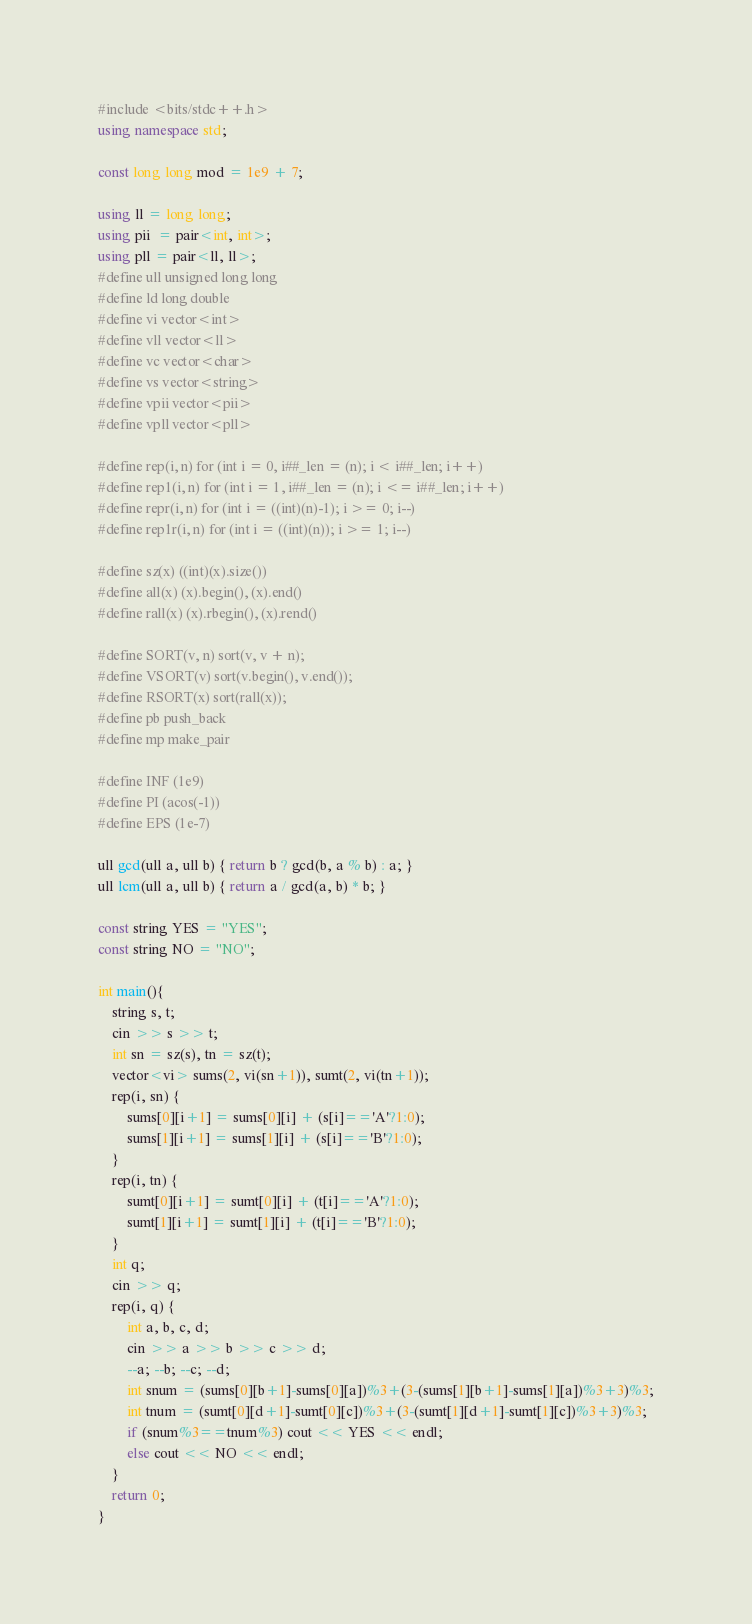Convert code to text. <code><loc_0><loc_0><loc_500><loc_500><_C++_>#include <bits/stdc++.h>
using namespace std;

const long long mod = 1e9 + 7;

using ll = long long;
using pii  = pair<int, int>;
using pll = pair<ll, ll>;
#define ull unsigned long long
#define ld long double
#define vi vector<int>
#define vll vector<ll>
#define vc vector<char>
#define vs vector<string>
#define vpii vector<pii>
#define vpll vector<pll>

#define rep(i, n) for (int i = 0, i##_len = (n); i < i##_len; i++)
#define rep1(i, n) for (int i = 1, i##_len = (n); i <= i##_len; i++)
#define repr(i, n) for (int i = ((int)(n)-1); i >= 0; i--)
#define rep1r(i, n) for (int i = ((int)(n)); i >= 1; i--)

#define sz(x) ((int)(x).size())
#define all(x) (x).begin(), (x).end()
#define rall(x) (x).rbegin(), (x).rend()

#define SORT(v, n) sort(v, v + n);
#define VSORT(v) sort(v.begin(), v.end());
#define RSORT(x) sort(rall(x));
#define pb push_back
#define mp make_pair

#define INF (1e9)
#define PI (acos(-1))
#define EPS (1e-7)

ull gcd(ull a, ull b) { return b ? gcd(b, a % b) : a; }
ull lcm(ull a, ull b) { return a / gcd(a, b) * b; }

const string YES = "YES";
const string NO = "NO";

int main(){
    string s, t;
    cin >> s >> t;
    int sn = sz(s), tn = sz(t);
    vector<vi> sums(2, vi(sn+1)), sumt(2, vi(tn+1));
    rep(i, sn) {
        sums[0][i+1] = sums[0][i] + (s[i]=='A'?1:0);
        sums[1][i+1] = sums[1][i] + (s[i]=='B'?1:0);
    }
    rep(i, tn) {
        sumt[0][i+1] = sumt[0][i] + (t[i]=='A'?1:0);
        sumt[1][i+1] = sumt[1][i] + (t[i]=='B'?1:0);
    }
    int q;
    cin >> q;
    rep(i, q) {
        int a, b, c, d;
        cin >> a >> b >> c >> d;
        --a; --b; --c; --d;
        int snum = (sums[0][b+1]-sums[0][a])%3+(3-(sums[1][b+1]-sums[1][a])%3+3)%3;
        int tnum = (sumt[0][d+1]-sumt[0][c])%3+(3-(sumt[1][d+1]-sumt[1][c])%3+3)%3;
        if (snum%3==tnum%3) cout << YES << endl;
        else cout << NO << endl;
    }
    return 0;
}
</code> 